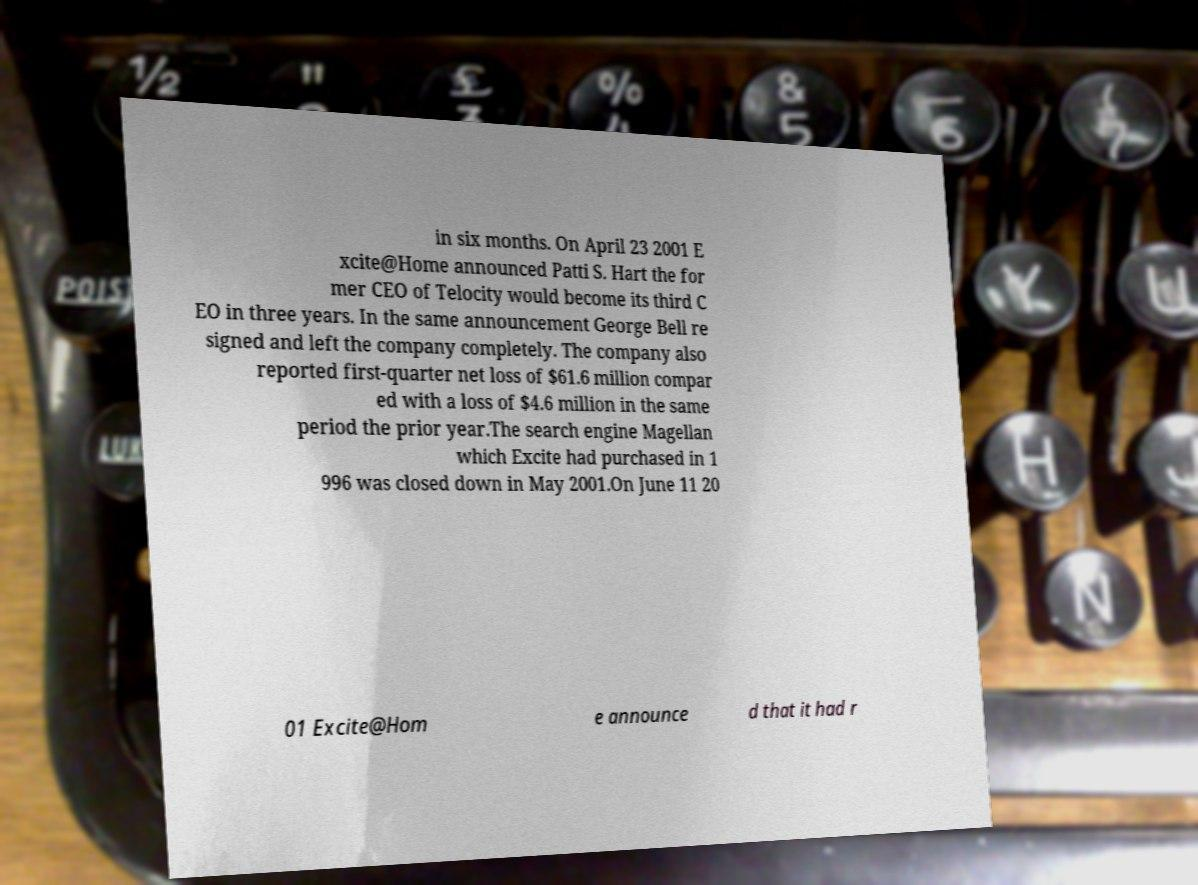Can you accurately transcribe the text from the provided image for me? in six months. On April 23 2001 E xcite@Home announced Patti S. Hart the for mer CEO of Telocity would become its third C EO in three years. In the same announcement George Bell re signed and left the company completely. The company also reported first-quarter net loss of $61.6 million compar ed with a loss of $4.6 million in the same period the prior year.The search engine Magellan which Excite had purchased in 1 996 was closed down in May 2001.On June 11 20 01 Excite@Hom e announce d that it had r 